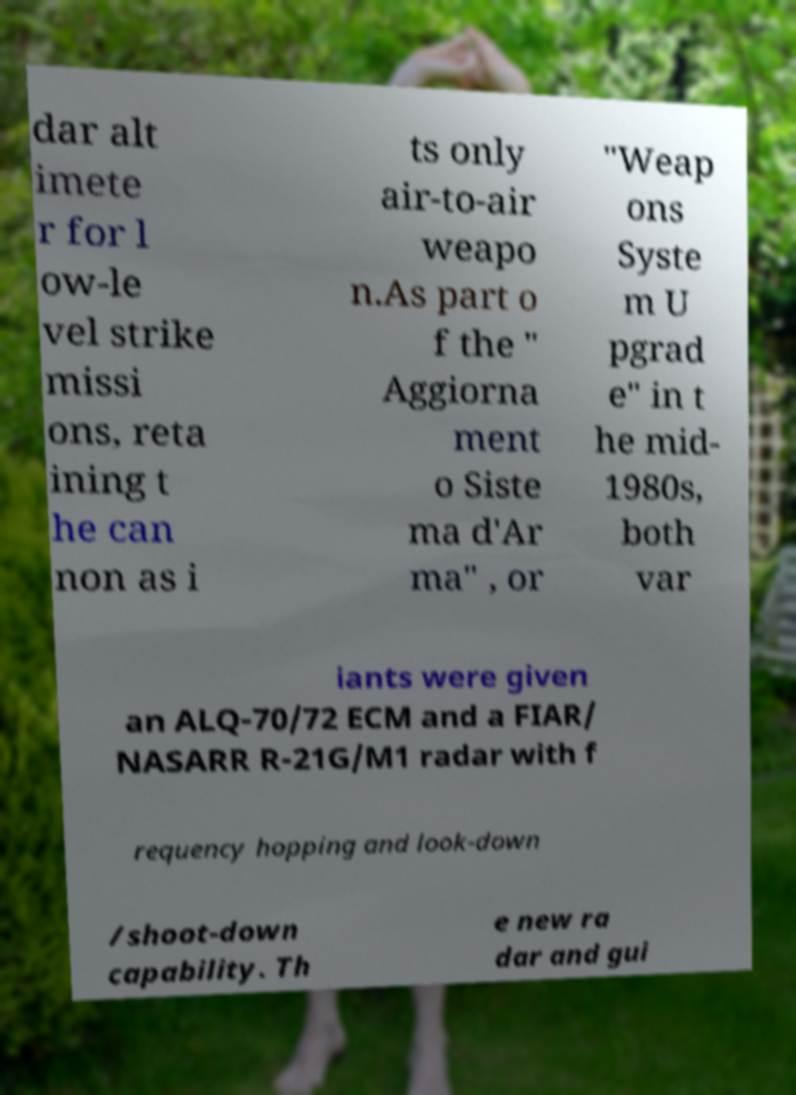For documentation purposes, I need the text within this image transcribed. Could you provide that? dar alt imete r for l ow-le vel strike missi ons, reta ining t he can non as i ts only air-to-air weapo n.As part o f the " Aggiorna ment o Siste ma d'Ar ma" , or "Weap ons Syste m U pgrad e" in t he mid- 1980s, both var iants were given an ALQ-70/72 ECM and a FIAR/ NASARR R-21G/M1 radar with f requency hopping and look-down /shoot-down capability. Th e new ra dar and gui 